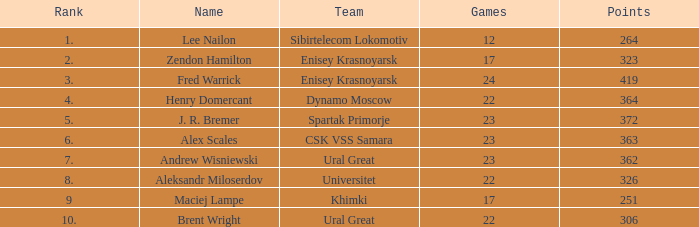What was the game with a rank higher than 2 and a name of zendon hamilton? None. 